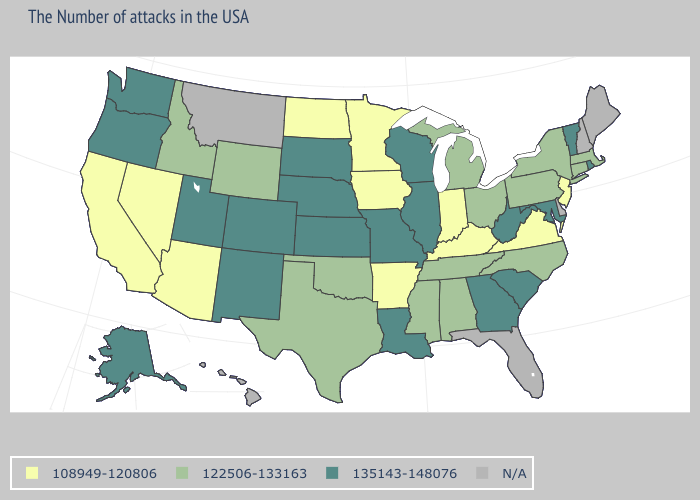What is the lowest value in the USA?
Keep it brief. 108949-120806. What is the value of Idaho?
Be succinct. 122506-133163. Among the states that border New York , which have the lowest value?
Keep it brief. New Jersey. Is the legend a continuous bar?
Answer briefly. No. Is the legend a continuous bar?
Concise answer only. No. Name the states that have a value in the range N/A?
Keep it brief. Maine, New Hampshire, Delaware, Florida, Montana, Hawaii. What is the value of Oregon?
Answer briefly. 135143-148076. What is the value of Indiana?
Answer briefly. 108949-120806. What is the value of South Dakota?
Be succinct. 135143-148076. Does the first symbol in the legend represent the smallest category?
Short answer required. Yes. Does Georgia have the lowest value in the USA?
Quick response, please. No. Which states have the lowest value in the USA?
Concise answer only. New Jersey, Virginia, Kentucky, Indiana, Arkansas, Minnesota, Iowa, North Dakota, Arizona, Nevada, California. Among the states that border Iowa , does Missouri have the highest value?
Short answer required. Yes. Which states have the lowest value in the USA?
Concise answer only. New Jersey, Virginia, Kentucky, Indiana, Arkansas, Minnesota, Iowa, North Dakota, Arizona, Nevada, California. 